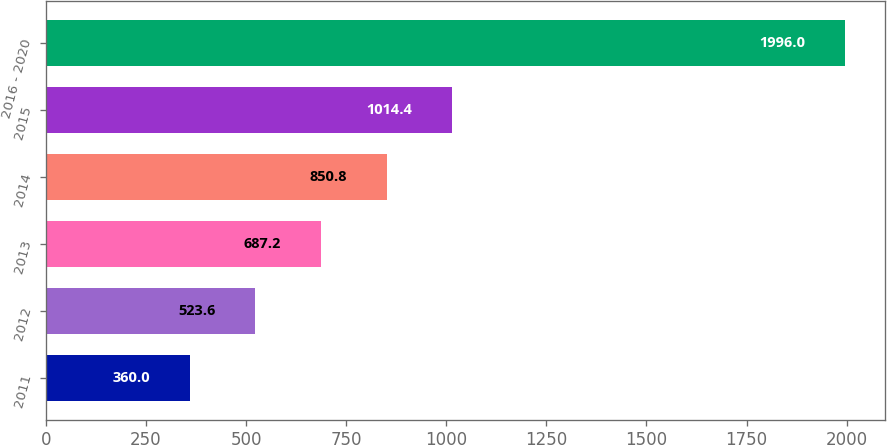<chart> <loc_0><loc_0><loc_500><loc_500><bar_chart><fcel>2011<fcel>2012<fcel>2013<fcel>2014<fcel>2015<fcel>2016 - 2020<nl><fcel>360<fcel>523.6<fcel>687.2<fcel>850.8<fcel>1014.4<fcel>1996<nl></chart> 